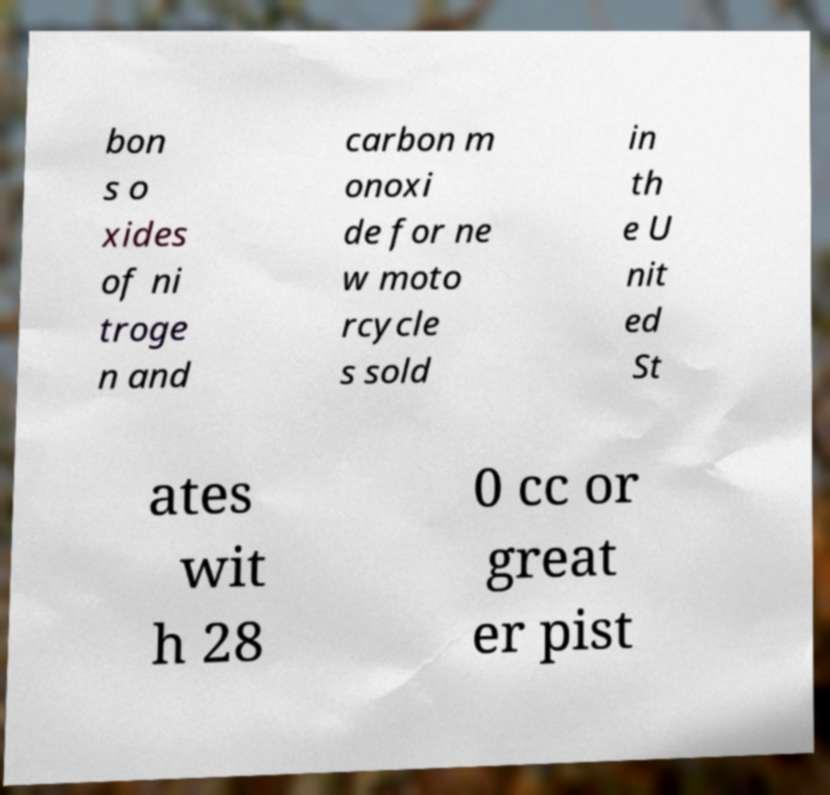Could you extract and type out the text from this image? bon s o xides of ni troge n and carbon m onoxi de for ne w moto rcycle s sold in th e U nit ed St ates wit h 28 0 cc or great er pist 